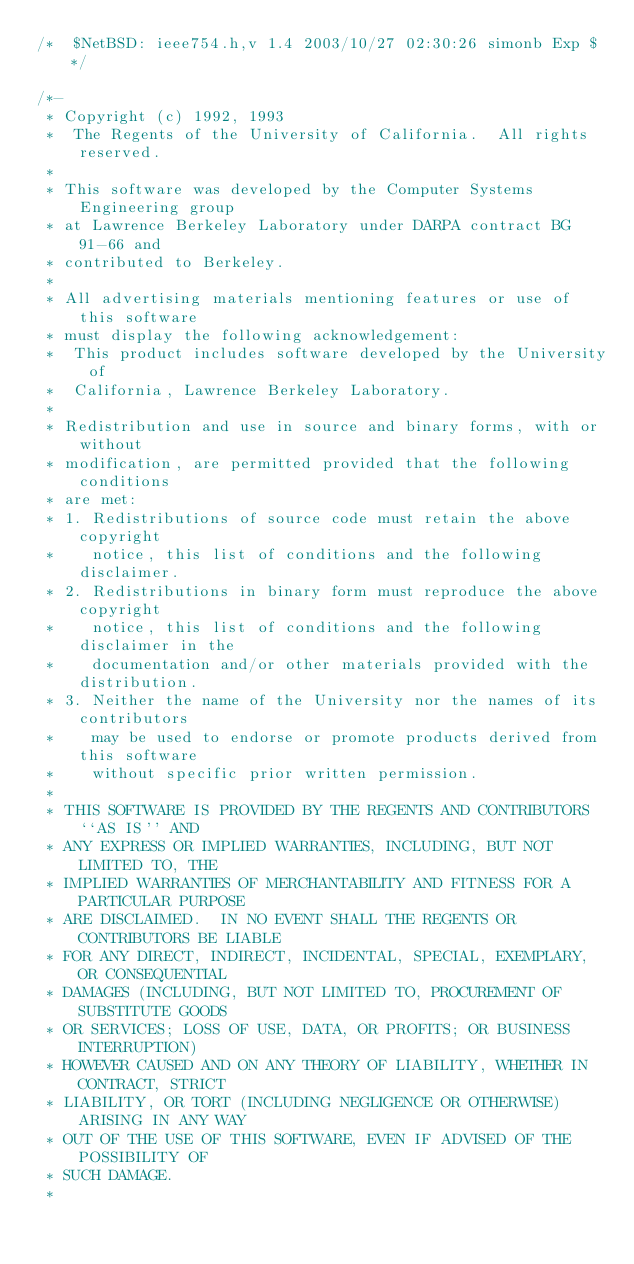<code> <loc_0><loc_0><loc_500><loc_500><_C_>/*	$NetBSD: ieee754.h,v 1.4 2003/10/27 02:30:26 simonb Exp $	*/

/*-
 * Copyright (c) 1992, 1993
 *	The Regents of the University of California.  All rights reserved.
 *
 * This software was developed by the Computer Systems Engineering group
 * at Lawrence Berkeley Laboratory under DARPA contract BG 91-66 and
 * contributed to Berkeley.
 *
 * All advertising materials mentioning features or use of this software
 * must display the following acknowledgement:
 *	This product includes software developed by the University of
 *	California, Lawrence Berkeley Laboratory.
 *
 * Redistribution and use in source and binary forms, with or without
 * modification, are permitted provided that the following conditions
 * are met:
 * 1. Redistributions of source code must retain the above copyright
 *    notice, this list of conditions and the following disclaimer.
 * 2. Redistributions in binary form must reproduce the above copyright
 *    notice, this list of conditions and the following disclaimer in the
 *    documentation and/or other materials provided with the distribution.
 * 3. Neither the name of the University nor the names of its contributors
 *    may be used to endorse or promote products derived from this software
 *    without specific prior written permission.
 *
 * THIS SOFTWARE IS PROVIDED BY THE REGENTS AND CONTRIBUTORS ``AS IS'' AND
 * ANY EXPRESS OR IMPLIED WARRANTIES, INCLUDING, BUT NOT LIMITED TO, THE
 * IMPLIED WARRANTIES OF MERCHANTABILITY AND FITNESS FOR A PARTICULAR PURPOSE
 * ARE DISCLAIMED.  IN NO EVENT SHALL THE REGENTS OR CONTRIBUTORS BE LIABLE
 * FOR ANY DIRECT, INDIRECT, INCIDENTAL, SPECIAL, EXEMPLARY, OR CONSEQUENTIAL
 * DAMAGES (INCLUDING, BUT NOT LIMITED TO, PROCUREMENT OF SUBSTITUTE GOODS
 * OR SERVICES; LOSS OF USE, DATA, OR PROFITS; OR BUSINESS INTERRUPTION)
 * HOWEVER CAUSED AND ON ANY THEORY OF LIABILITY, WHETHER IN CONTRACT, STRICT
 * LIABILITY, OR TORT (INCLUDING NEGLIGENCE OR OTHERWISE) ARISING IN ANY WAY
 * OUT OF THE USE OF THIS SOFTWARE, EVEN IF ADVISED OF THE POSSIBILITY OF
 * SUCH DAMAGE.
 *</code> 